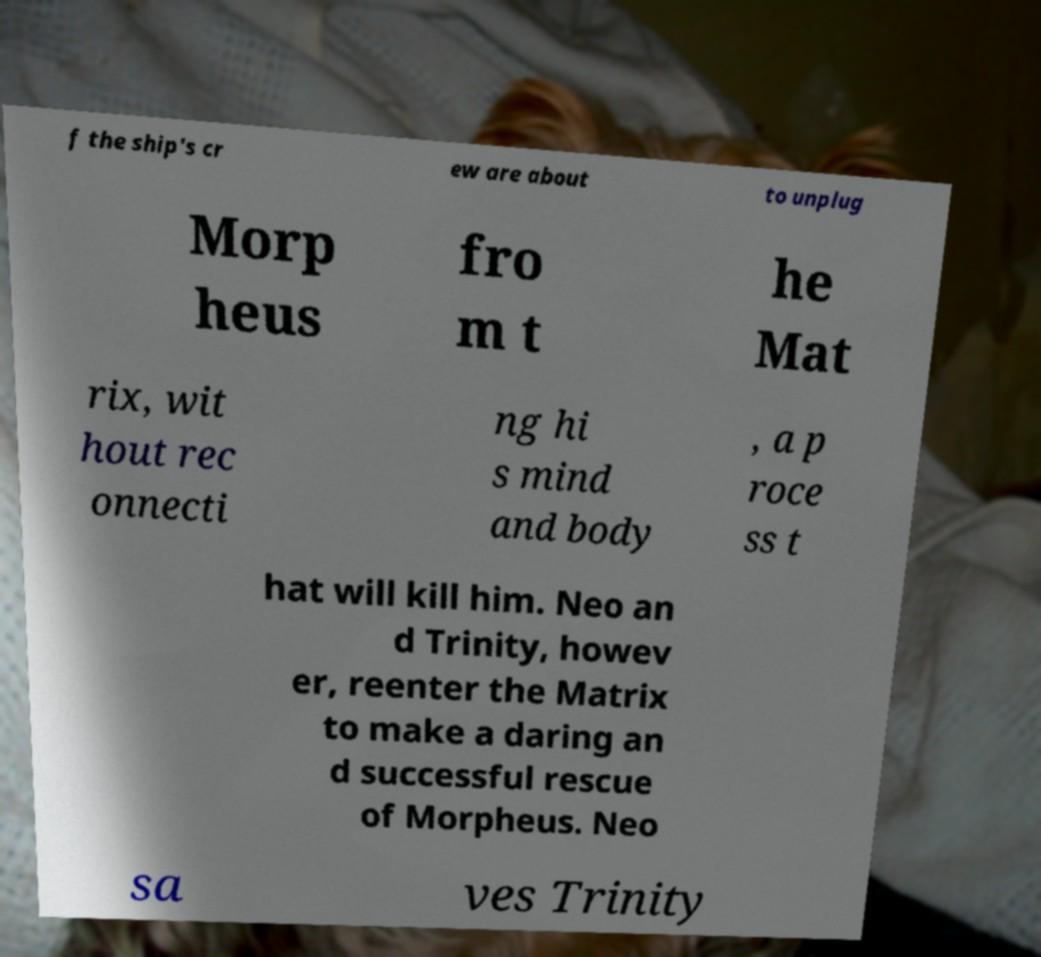There's text embedded in this image that I need extracted. Can you transcribe it verbatim? f the ship's cr ew are about to unplug Morp heus fro m t he Mat rix, wit hout rec onnecti ng hi s mind and body , a p roce ss t hat will kill him. Neo an d Trinity, howev er, reenter the Matrix to make a daring an d successful rescue of Morpheus. Neo sa ves Trinity 